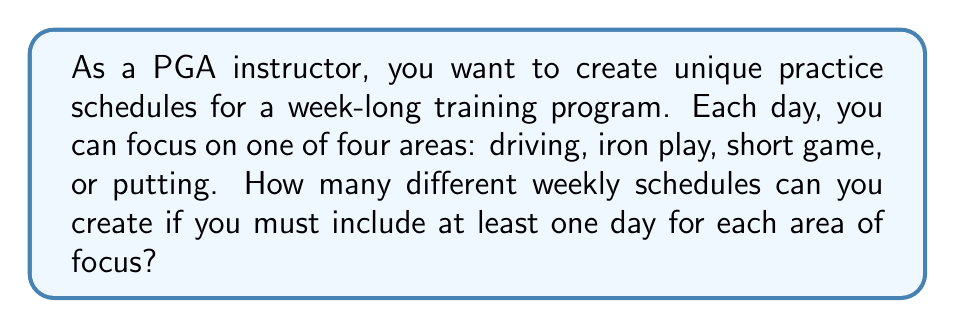Teach me how to tackle this problem. Let's approach this step-by-step:

1) We have 7 days and 4 areas of focus. We must use each area at least once, which accounts for 4 days.

2) This leaves 3 days that can be assigned to any of the 4 areas.

3) This is a problem of distributing 3 indistinguishable objects (the remaining 3 days) into 4 distinguishable boxes (the 4 areas of focus).

4) The formula for this type of problem is:

   $${n+k-1 \choose k}$$

   Where $n$ is the number of distinguishable boxes (4 in this case) and $k$ is the number of indistinguishable objects (3 in this case).

5) Plugging in our values:

   $${4+3-1 \choose 3} = {6 \choose 3}$$

6) We can calculate this as:

   $$\frac{6!}{3!(6-3)!} = \frac{6!}{3!3!} = \frac{6 \times 5 \times 4}{3 \times 2 \times 1} = 20$$

Therefore, there are 20 different ways to distribute the remaining 3 days.

7) However, this only accounts for the distribution of the extra days. We need to consider the ordering of all 7 days.

8) For each of these 20 distributions, we can arrange the 7 days in 7! ways.

9) Thus, the total number of unique schedules is:

   $$20 \times 7! = 20 \times 5040 = 100,800$$
Answer: 100,800 unique weekly schedules 